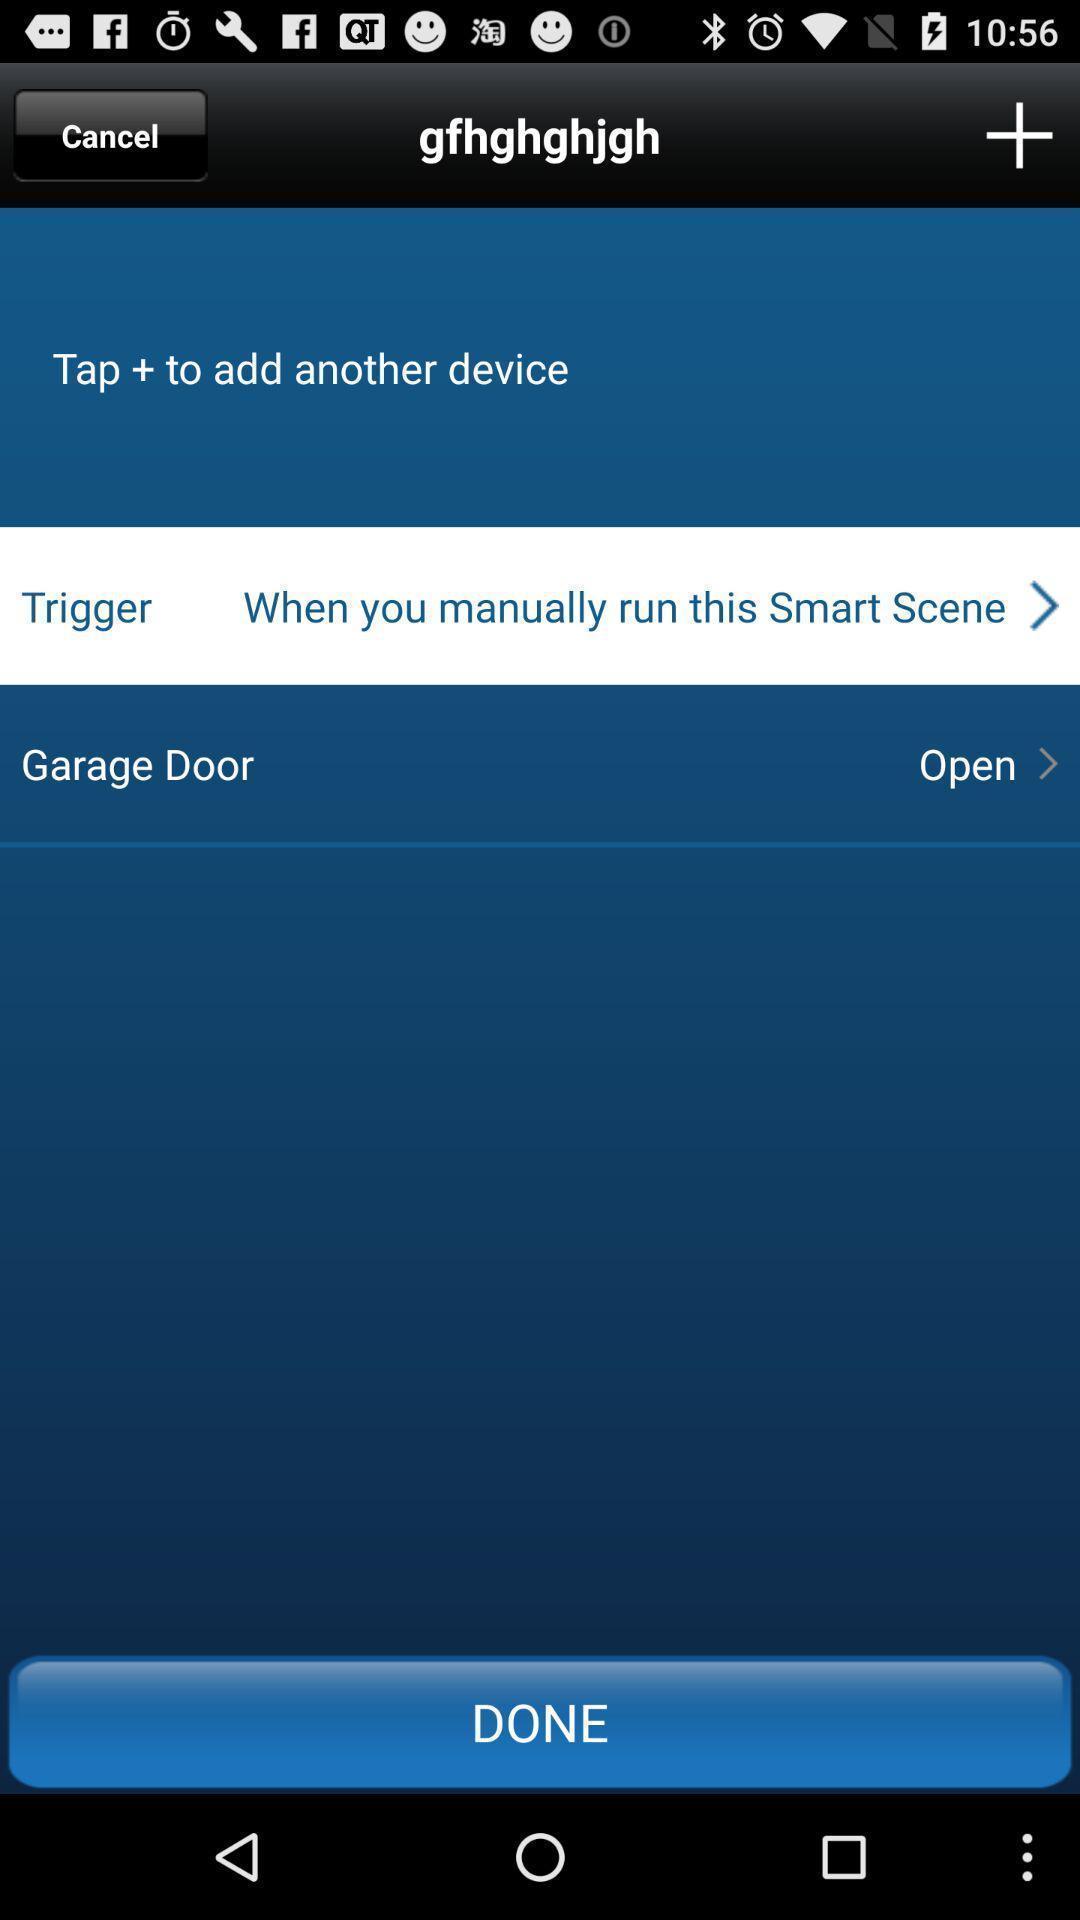Give me a narrative description of this picture. Page with edit details in a support page. 